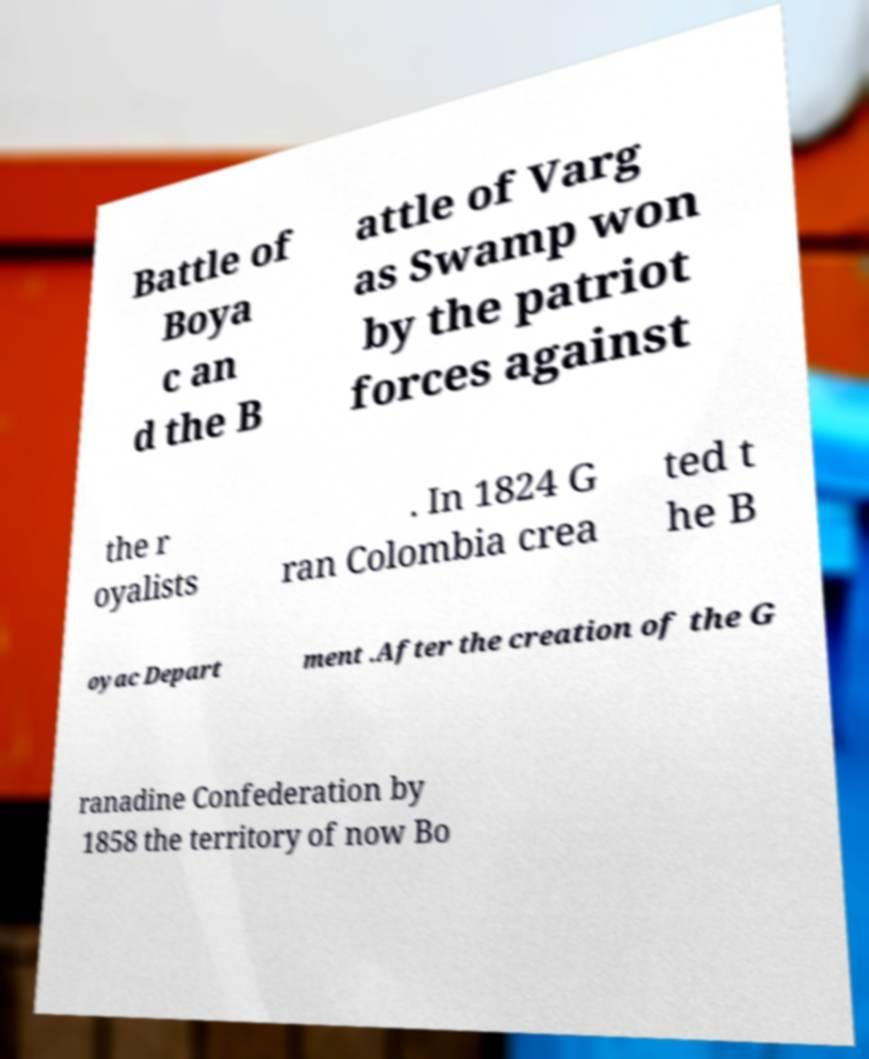For documentation purposes, I need the text within this image transcribed. Could you provide that? Battle of Boya c an d the B attle of Varg as Swamp won by the patriot forces against the r oyalists . In 1824 G ran Colombia crea ted t he B oyac Depart ment .After the creation of the G ranadine Confederation by 1858 the territory of now Bo 